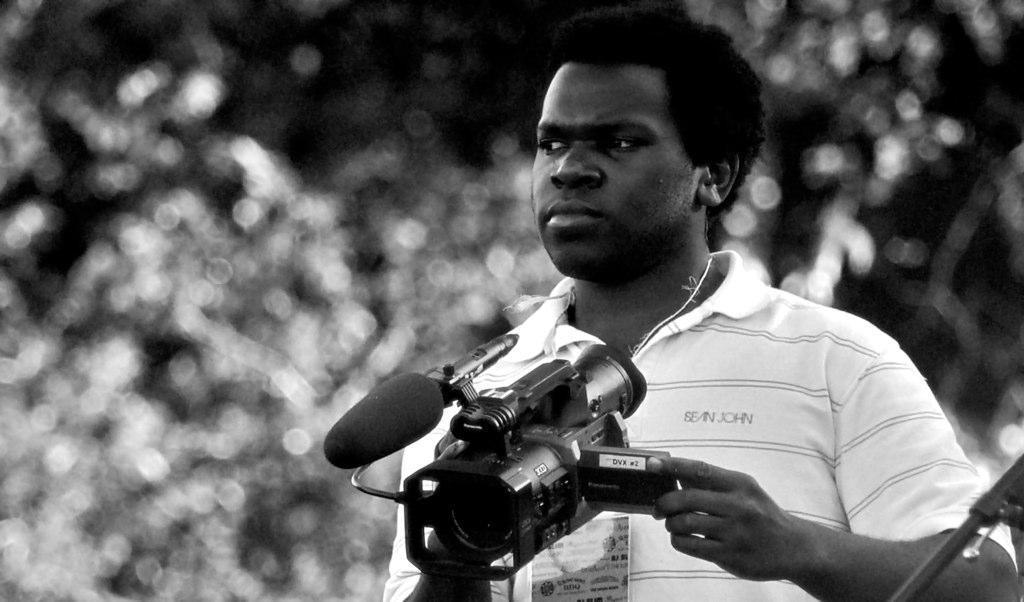Describe this image in one or two sentences. Here we can see a man who is holding a camera with his hands. 